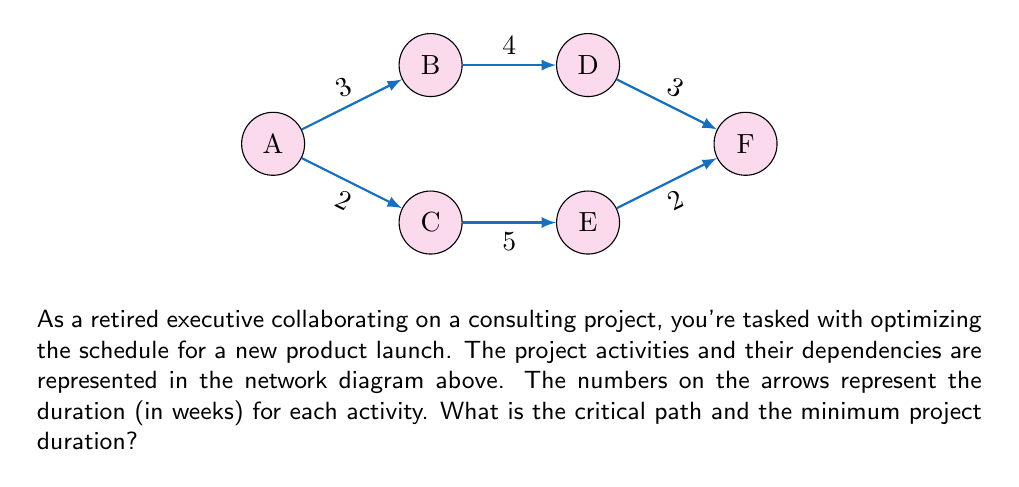Help me with this question. To solve this problem, we'll use the critical path method (CPM). Let's follow these steps:

1) Identify all paths from start (A) to finish (F):
   Path 1: A → B → D → F
   Path 2: A → C → E → F

2) Calculate the duration of each path:
   Path 1: A → B (3) → D (4) → F (3) = 10 weeks
   Path 2: A → C (2) → E (5) → F (2) = 9 weeks

3) The critical path is the longest path, which determines the minimum project duration. In this case, it's Path 1 (A → B → D → F) with a duration of 10 weeks.

4) We can verify this by calculating the early start (ES) and late start (LS) times for each activity:

   A: ES = 0, LS = 0
   B: ES = 0, LS = 0
   C: ES = 0, LS = 1
   D: ES = 3, LS = 3
   E: ES = 2, LS = 3
   F: ES = 7, LS = 7

   Activities on the critical path have ES = LS, which confirms A → B → D → F as the critical path.

5) The minimum project duration is the length of the critical path, which is 10 weeks.
Answer: Critical path: A → B → D → F; Minimum duration: 10 weeks 